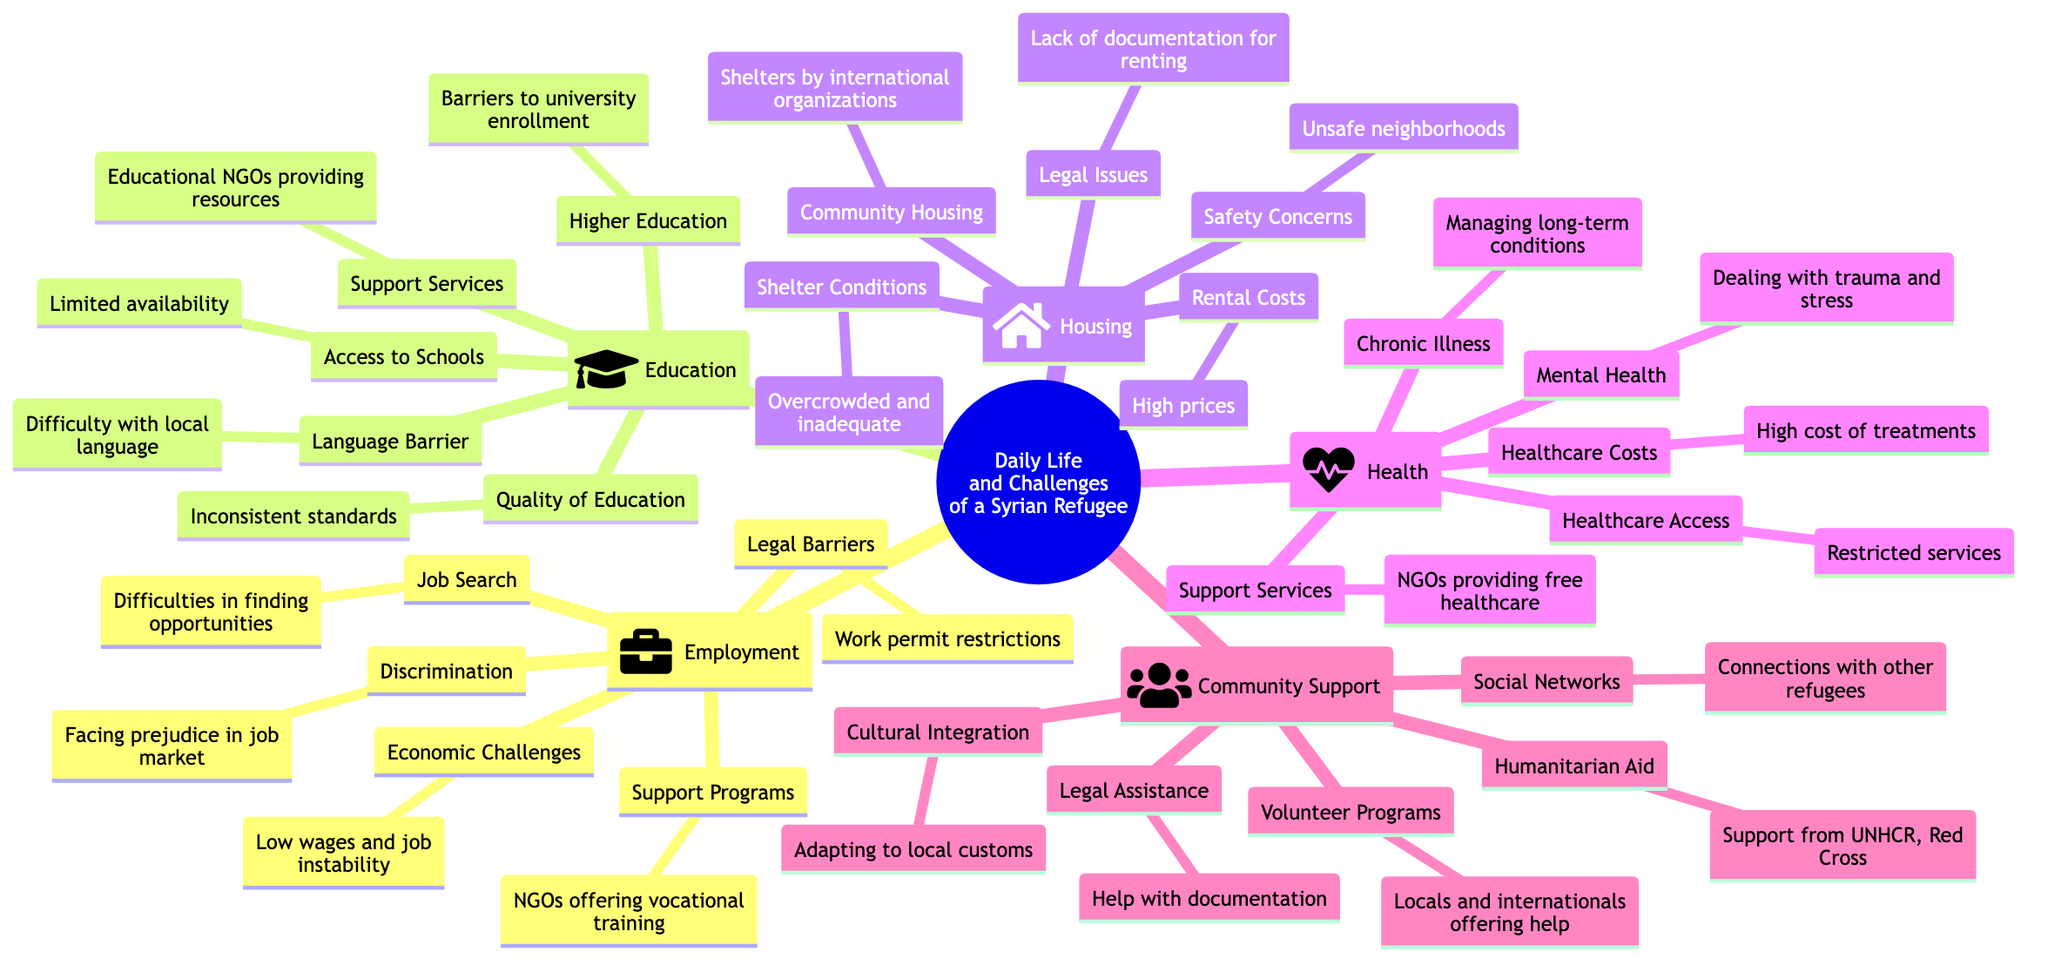What are the main categories outlined in the diagram? The main categories are Employment, Education, Housing, Health, and Community Support. Each of these represents a significant area of concern for Syrian refugees, as visually grouped in the mind map.
Answer: Employment, Education, Housing, Health, Community Support How many subcategories are listed under Health? There are five subcategories listed under the Health category: Healthcare Access, Mental Health, Chronic Illness, Healthcare Costs, and Support Services. Counting these gives the total number.
Answer: 5 What kind of challenges are associated with Employment? The challenges associated with Employment include Job Search difficulties, Legal Barriers, Discrimination, Economic Challenges, and Support Programs. Each challenge reflects a different aspect of the difficulties refugees face in finding work.
Answer: Job Search, Legal Barriers, Discrimination, Economic Challenges, Support Programs What is a main barrier to Higher Education as noted in the diagram? The main barrier to Higher Education is "Barriers to university enrollment," which indicates that refugees face specific obstacles that prevent them from accessing higher education opportunities.
Answer: Barriers to university enrollment Which category provides support for mental health issues? The Health category provides support for mental health issues, specifically highlighting the need to deal with trauma and stress. This implies there are services available to address mental health.
Answer: Health How does Community Support aid refugees according to the diagram? Community Support aids refugees through Social Networks, Cultural Integration, Legal Assistance, Humanitarian Aid, and Volunteer Programs. This shows the various ways communities help refugees adapt and survive.
Answer: Social Networks, Cultural Integration, Legal Assistance, Humanitarian Aid, Volunteer Programs What type of assistance do NGOs provide related to Health? NGOs provide Support Services, including free healthcare for refugees. This highlights the role of these organizations in addressing health challenges in the refugee population.
Answer: NGOs providing free healthcare What are the rental costs described in the Housing section? The Rental Costs under Housing are described as "High rental prices." This summarization indicates the affordability issues refugees face when securing housing.
Answer: High rental prices How does Discrimination affect job prospects for refugees? Discrimination affects job prospects by causing prejudice in the job market, which may lead to fewer opportunities or lower chances of being hired compared to others. This highlights a social barrier to employment.
Answer: Facing prejudice in job market 